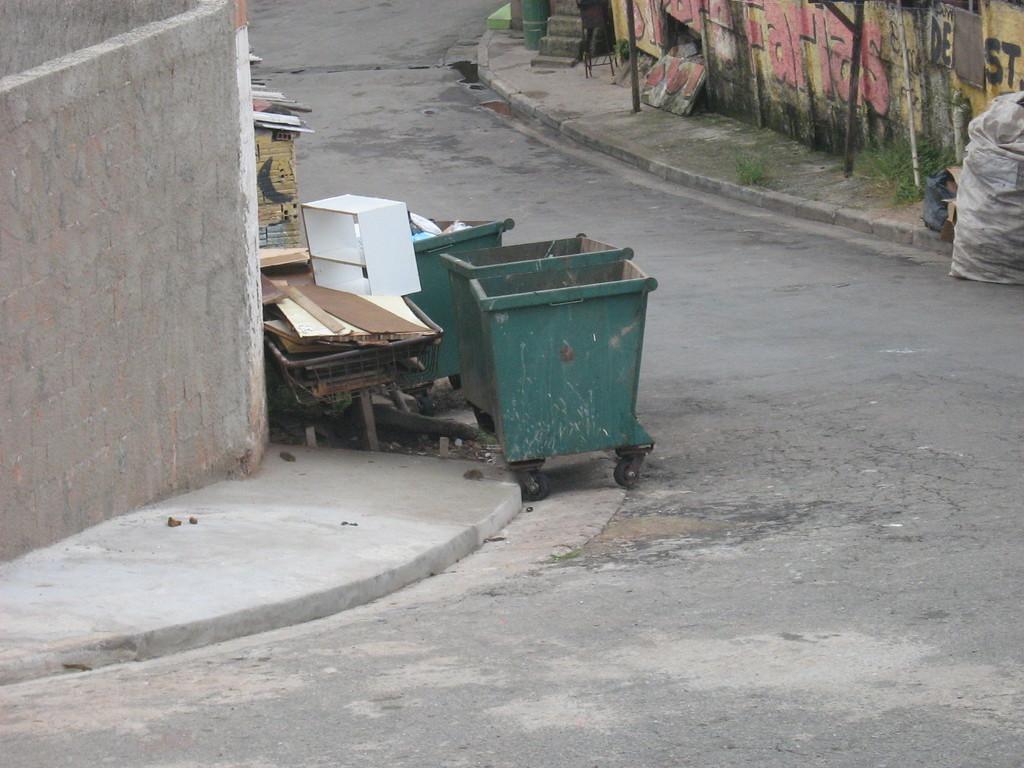Can you describe this image briefly? In this image there is a road and we can see trolleys, stand, wooden blocks and a gunny bag placed on the road. There are rods and we can see walls. 